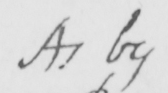What text is written in this handwritten line? As by 